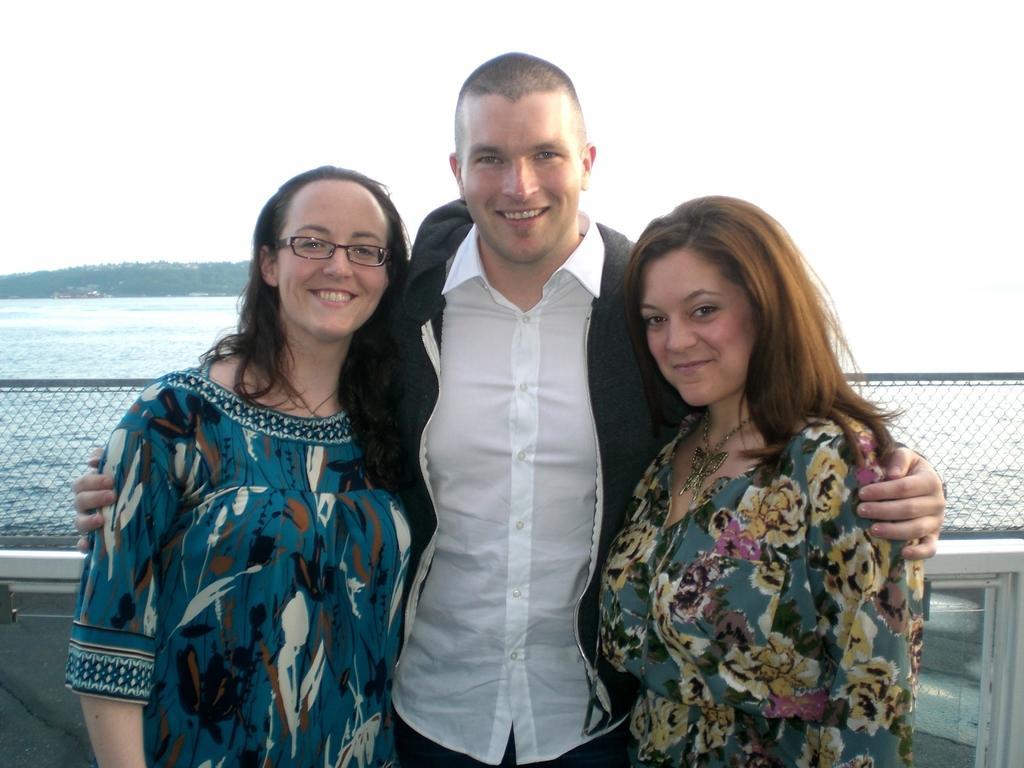Describe this image in one or two sentences. In this picture we can see three people standing, smiling and at the back of them we can see the water, fence, some objects and in the background we can see white color. 